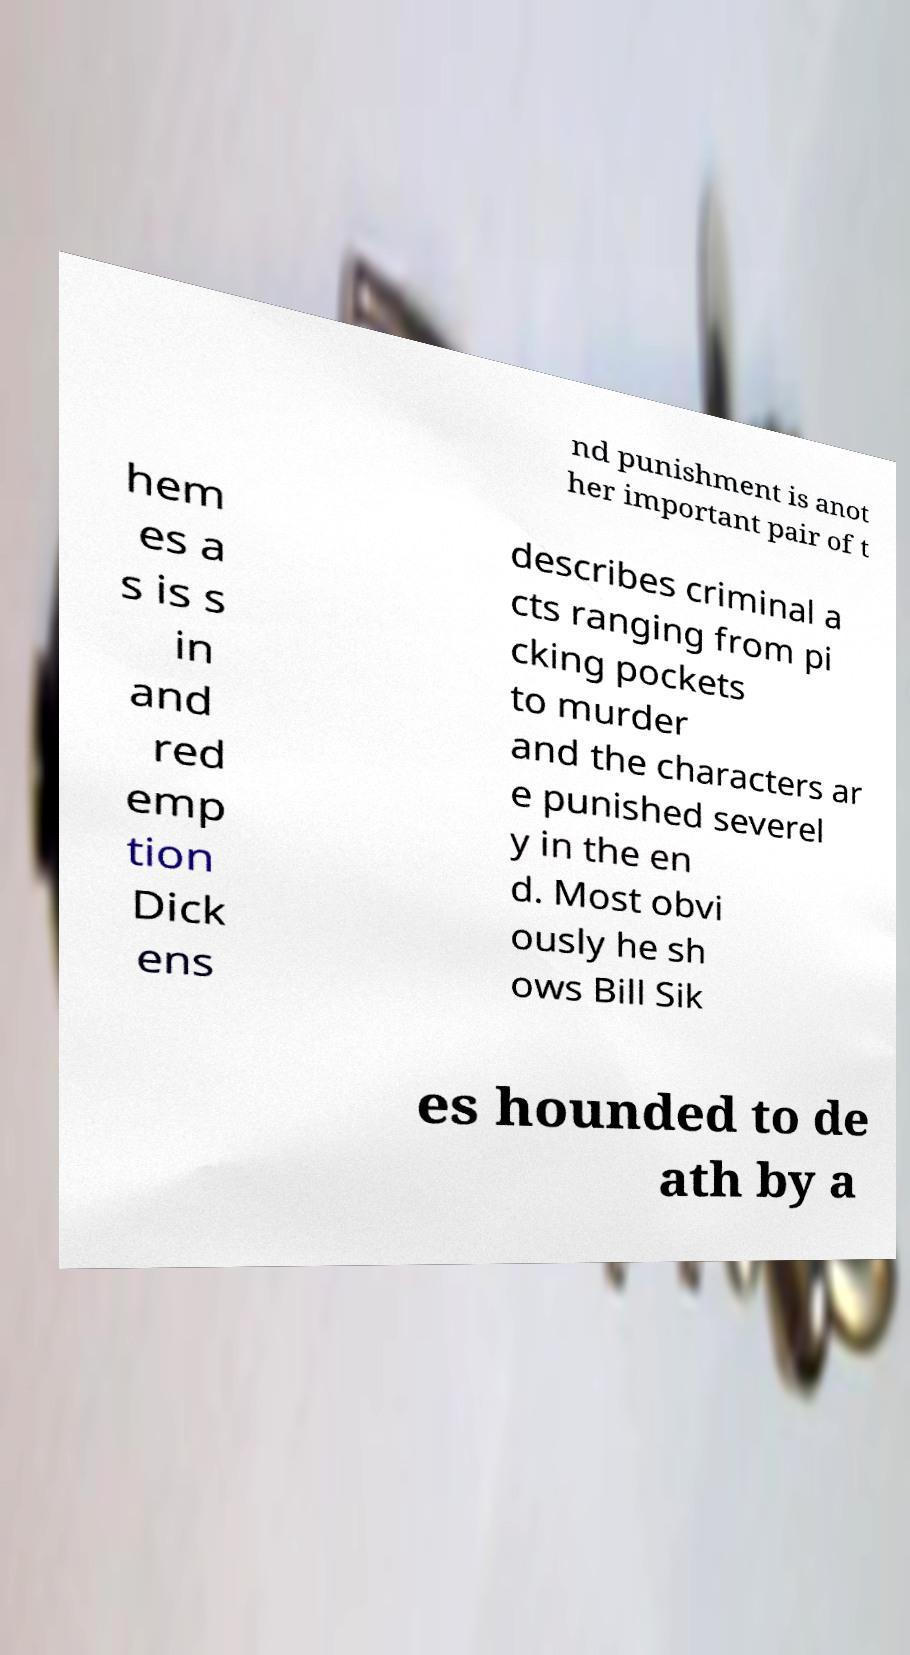Please read and relay the text visible in this image. What does it say? nd punishment is anot her important pair of t hem es a s is s in and red emp tion Dick ens describes criminal a cts ranging from pi cking pockets to murder and the characters ar e punished severel y in the en d. Most obvi ously he sh ows Bill Sik es hounded to de ath by a 